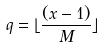Convert formula to latex. <formula><loc_0><loc_0><loc_500><loc_500>q = \lfloor \frac { ( x - 1 ) } { M } \rfloor</formula> 